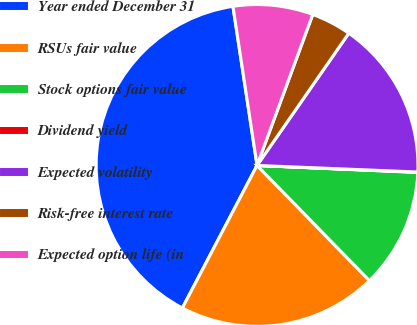<chart> <loc_0><loc_0><loc_500><loc_500><pie_chart><fcel>Year ended December 31<fcel>RSUs fair value<fcel>Stock options fair value<fcel>Dividend yield<fcel>Expected volatility<fcel>Risk-free interest rate<fcel>Expected option life (in<nl><fcel>39.94%<fcel>19.99%<fcel>12.01%<fcel>0.04%<fcel>16.0%<fcel>4.03%<fcel>8.02%<nl></chart> 